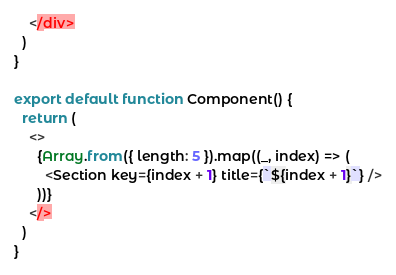Convert code to text. <code><loc_0><loc_0><loc_500><loc_500><_TypeScript_>    </div>
  )
}

export default function Component() {
  return (
    <>
      {Array.from({ length: 5 }).map((_, index) => (
        <Section key={index + 1} title={`${index + 1}`} />
      ))}
    </>
  )
}
</code> 